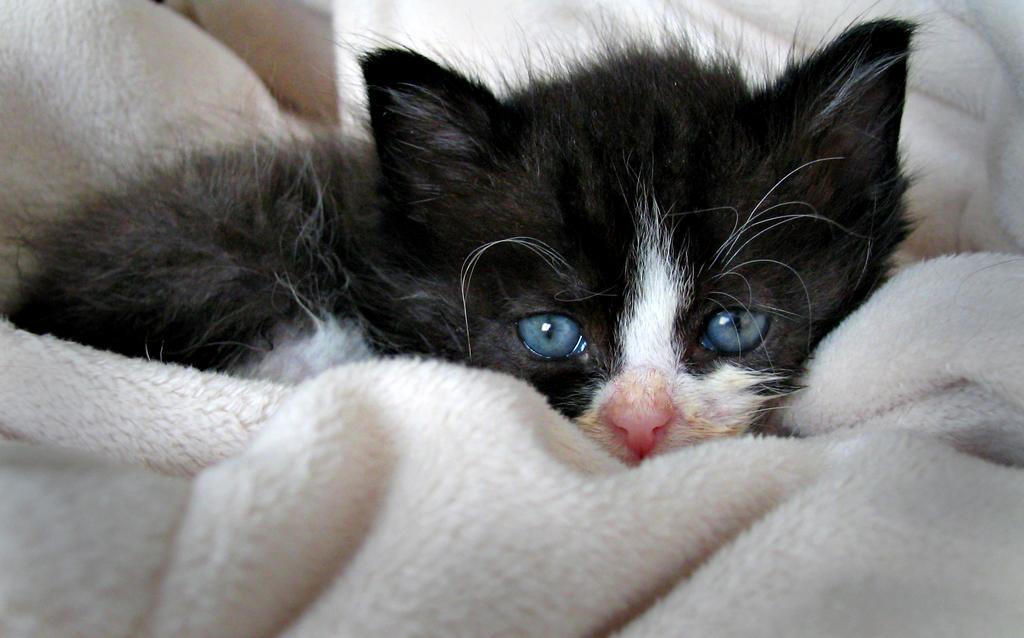Could you give a brief overview of what you see in this image? Here we can see a cat sitting on a cloth. 